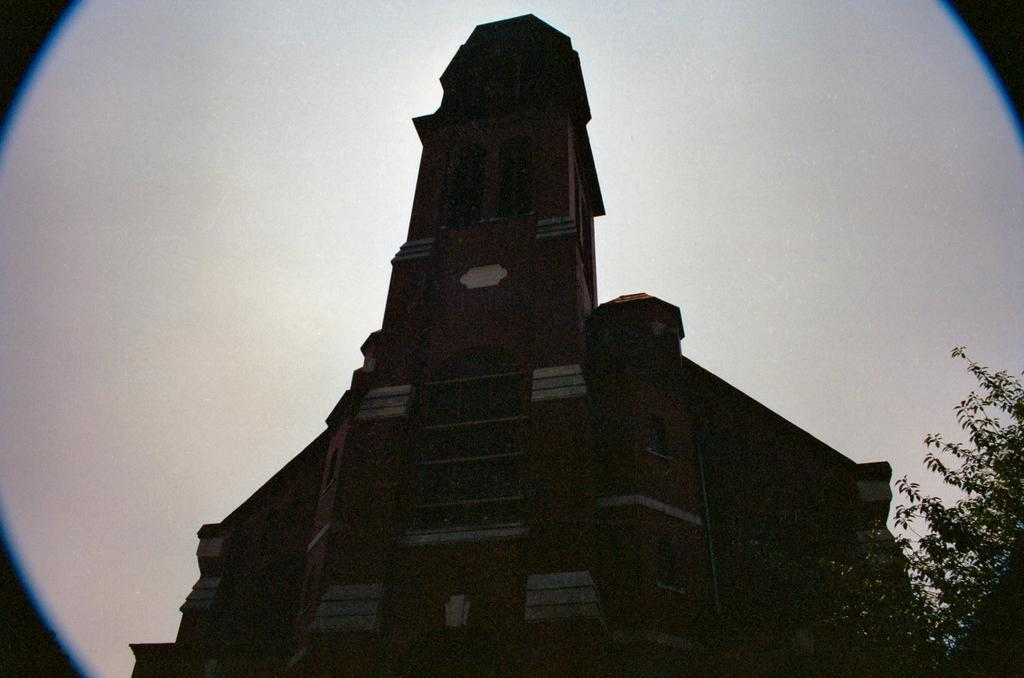What type of structure is visible in the image? There is a building with windows in the image. What color is the background in the image? The background is white. Where is the tree located in the image? The tree is in the right bottom corner of the image. What type of vest is the friend wearing in the image? There is no friend or vest present in the image. How many chickens can be seen in the image? There are no chickens present in the image. 